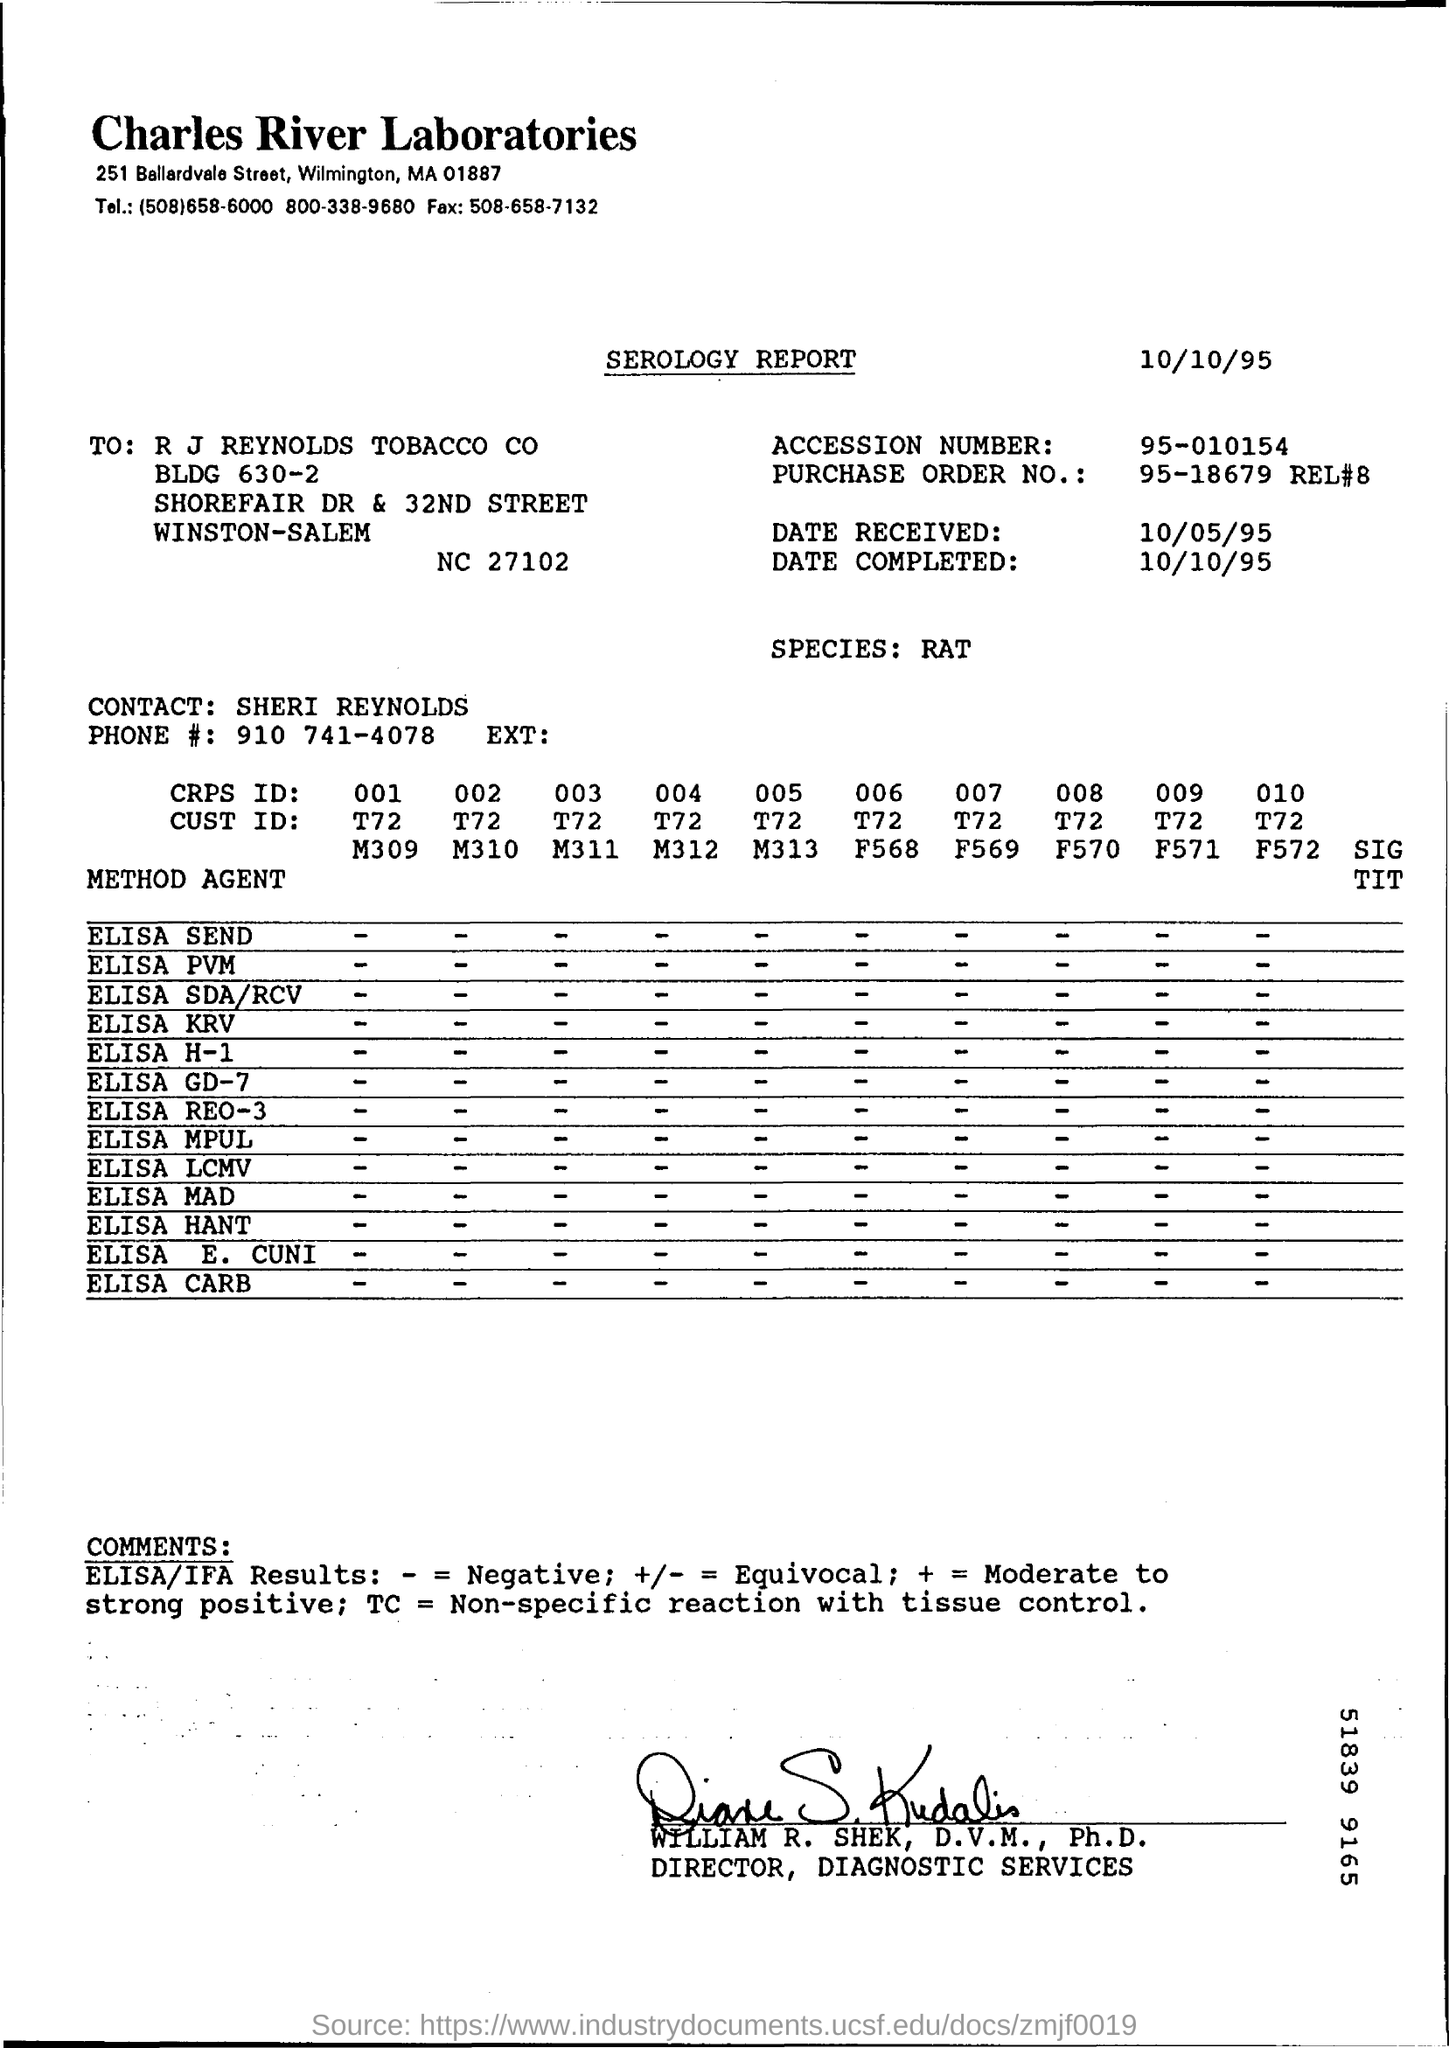Specify some key components in this picture. The serology report is mentioned. The report pertains to the species of rat. The laboratory's name is Charles River Laboratories. The serology report was completed on October 10, 1995. Charles River Laboratories is located in Wilmington, a city in the United States. 